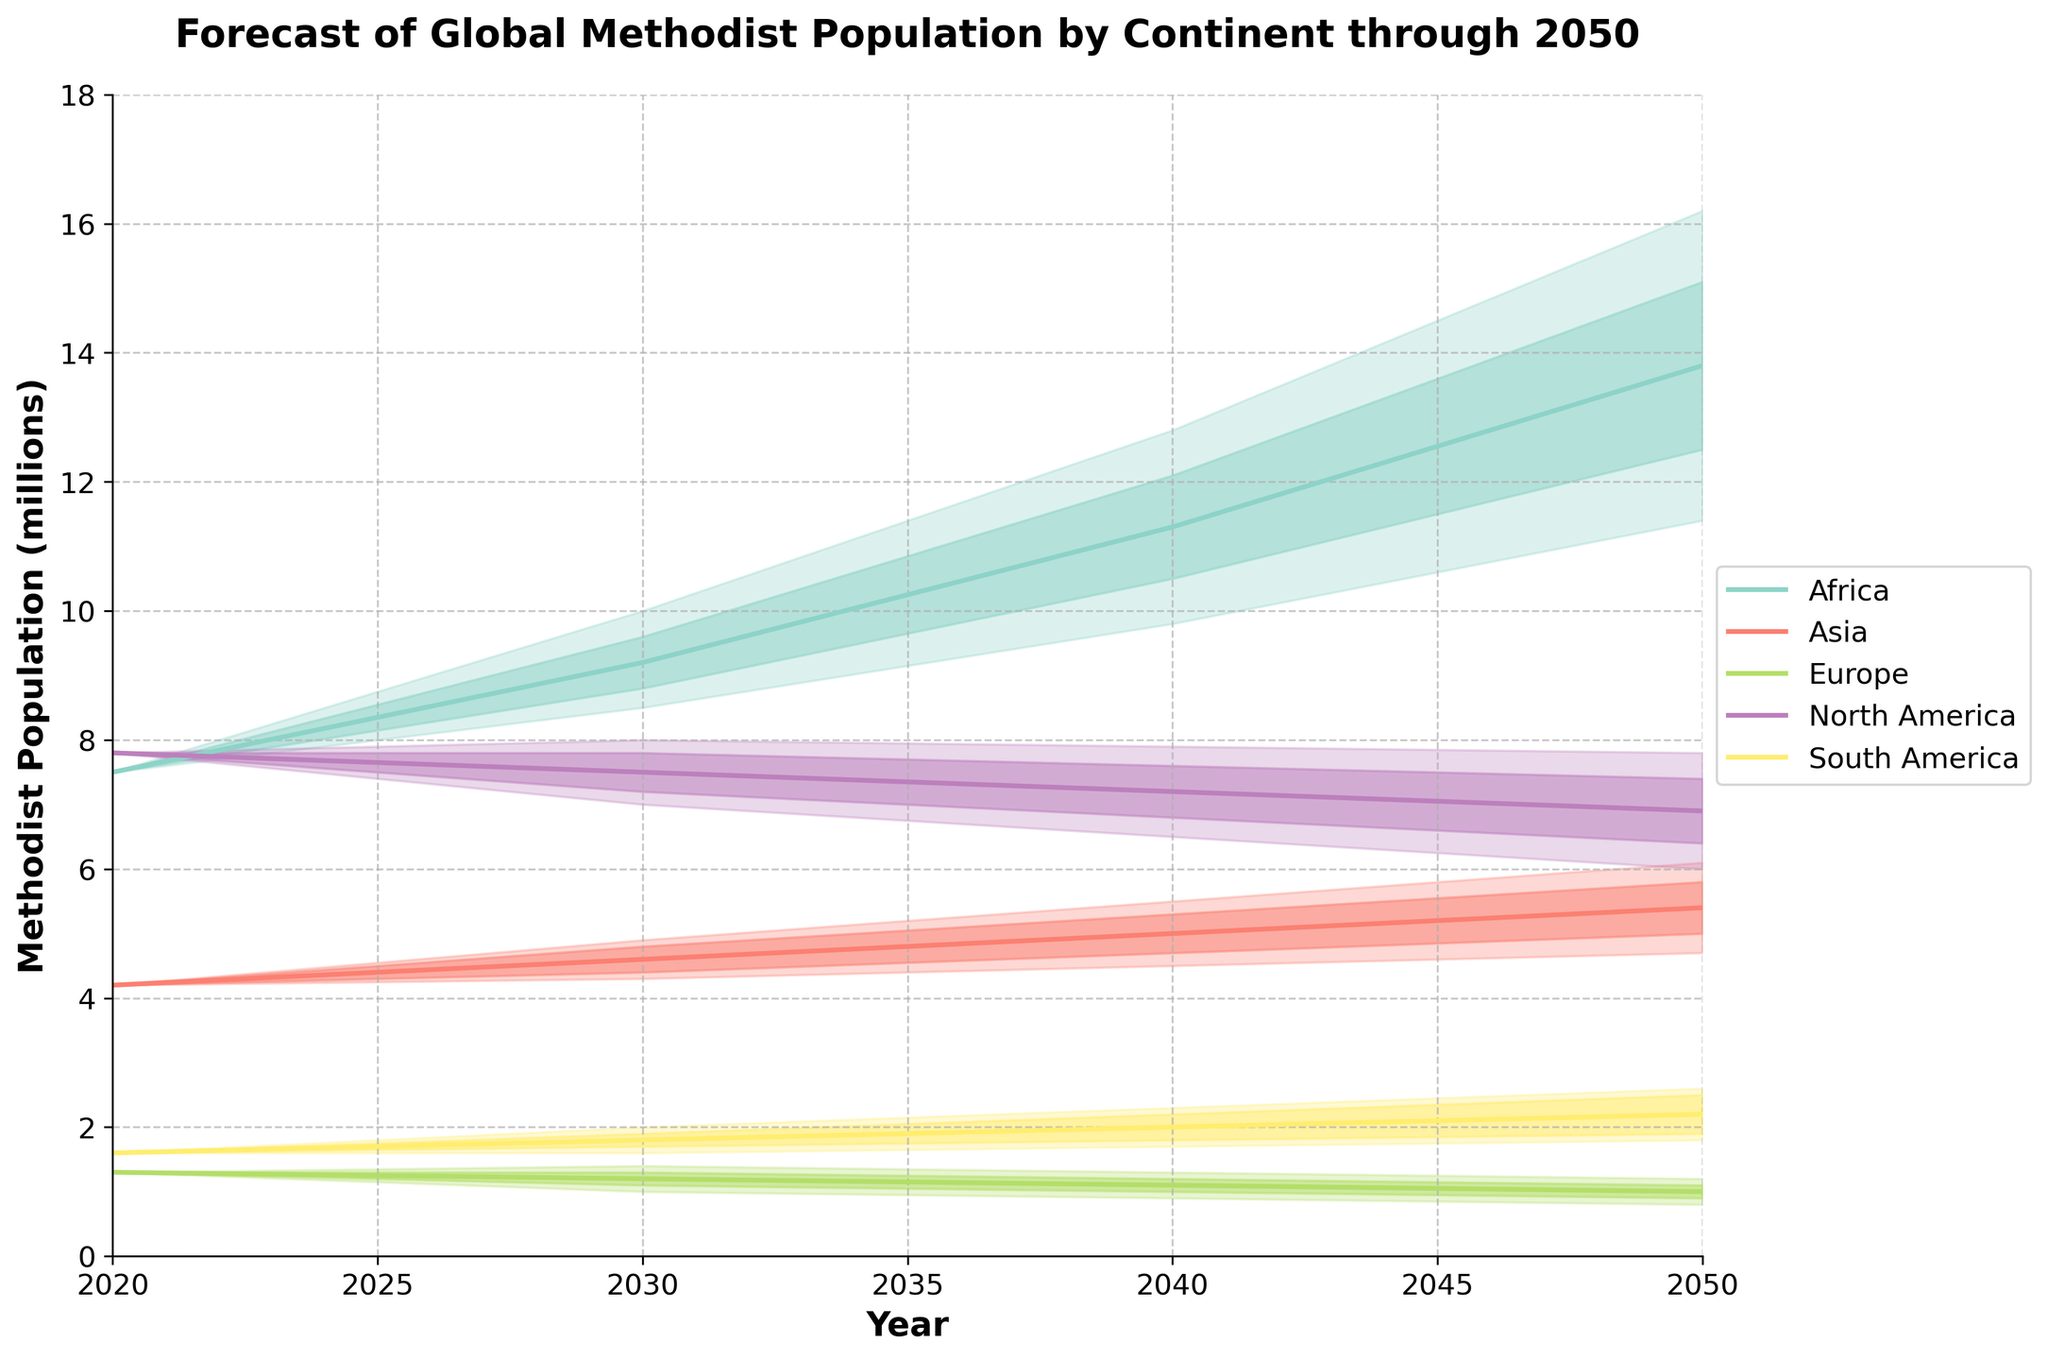What is the title of the figure? The title of the figure is written at the top of the chart.
Answer: Forecast of Global Methodist Population by Continent through 2050 What are the labels of the x-axis and y-axis? The labels of the x-axis and y-axis are found at the bottom and left side of the chart, respectively.
Answer: Year, Methodist Population (millions) Which continent is expected to have the highest median Methodist population in 2050? By looking at the median lines for each continent in 2050, Africa has the highest median value.
Answer: Africa What is the forecasted range (Low10 to High10) of the Methodist population in North America for 2030? By identifying the Low10 and High10 values for North America in 2030, we see the range.
Answer: 7.2 to 7.8 million Between which years does Africa show the most significant increase in median population? By comparing the slopes of the median lines for Africa between different decades, the increase from 2040 to 2050 is the most significant.
Answer: 2040 to 2050 How does the anticipated population trend in Europe compare to that in Asia? Observing the median lines, Europe shows a downward trend, while Asia shows an upward trend in population from 2020 to 2050.
Answer: Europe's population decreases; Asia's population increases What are the continent colors used in the chart, and which color represents South America? By looking at the legend, each continent is assigned a specific color, matched with South America.
Answer: The color representing South America In 2040, which continent has the smallest forecasted range (Low20 to High20) and what is it? By comparing the Low20 to High20 ranges in 2040, Asia has the smallest range.
Answer: Asia, 4.5 to 5.5 million Is the Methodist population in North America expected to increase or decrease by 2050? Observing the median line for North America, it shows a decreasing trend from 2020 to 2050.
Answer: Decrease 